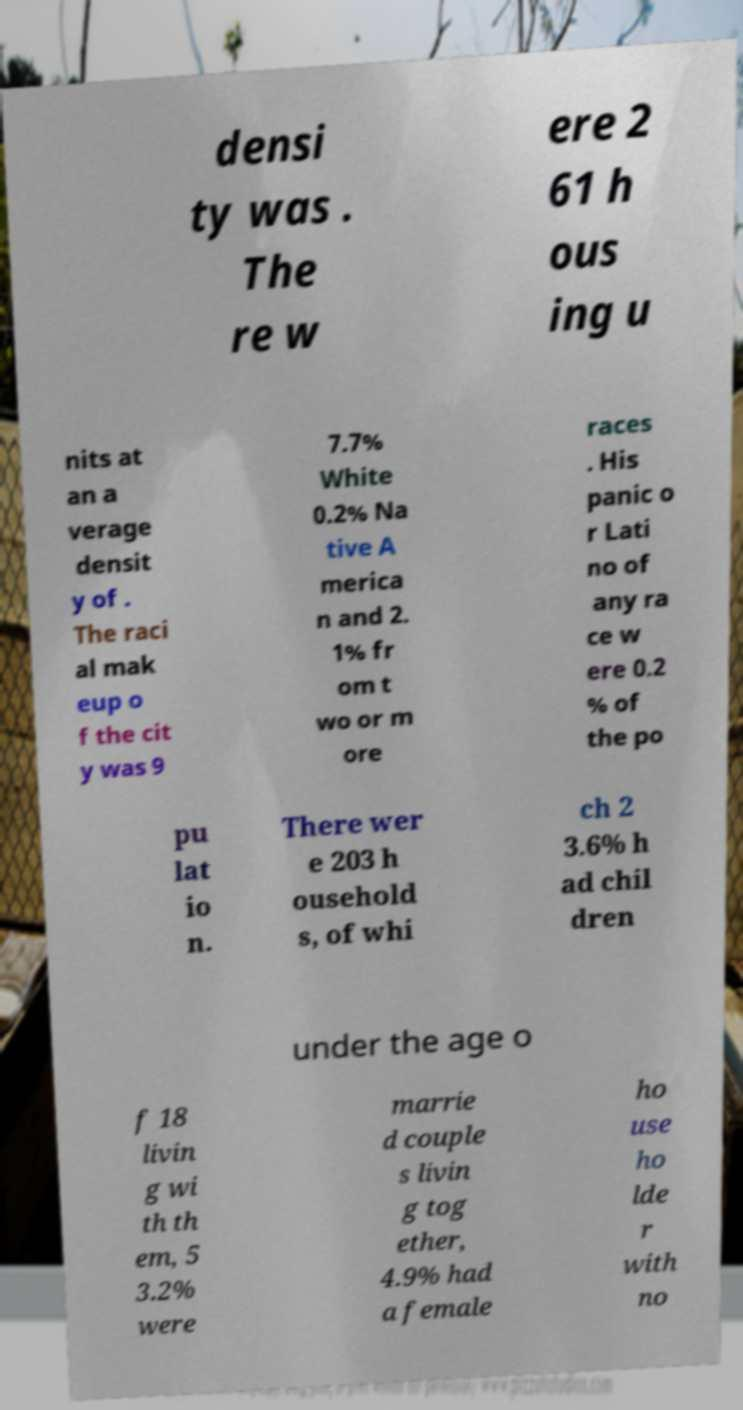For documentation purposes, I need the text within this image transcribed. Could you provide that? densi ty was . The re w ere 2 61 h ous ing u nits at an a verage densit y of . The raci al mak eup o f the cit y was 9 7.7% White 0.2% Na tive A merica n and 2. 1% fr om t wo or m ore races . His panic o r Lati no of any ra ce w ere 0.2 % of the po pu lat io n. There wer e 203 h ousehold s, of whi ch 2 3.6% h ad chil dren under the age o f 18 livin g wi th th em, 5 3.2% were marrie d couple s livin g tog ether, 4.9% had a female ho use ho lde r with no 